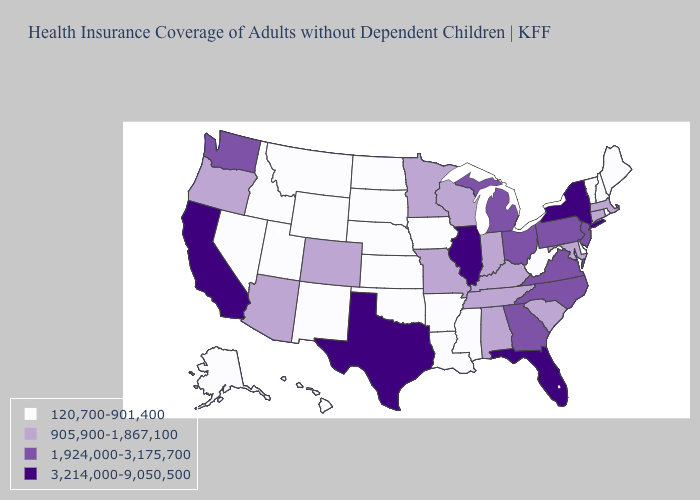What is the value of Florida?
Give a very brief answer. 3,214,000-9,050,500. What is the highest value in the USA?
Concise answer only. 3,214,000-9,050,500. Is the legend a continuous bar?
Keep it brief. No. Name the states that have a value in the range 120,700-901,400?
Give a very brief answer. Alaska, Arkansas, Delaware, Hawaii, Idaho, Iowa, Kansas, Louisiana, Maine, Mississippi, Montana, Nebraska, Nevada, New Hampshire, New Mexico, North Dakota, Oklahoma, Rhode Island, South Dakota, Utah, Vermont, West Virginia, Wyoming. Name the states that have a value in the range 3,214,000-9,050,500?
Answer briefly. California, Florida, Illinois, New York, Texas. Which states have the lowest value in the Northeast?
Answer briefly. Maine, New Hampshire, Rhode Island, Vermont. What is the value of Indiana?
Give a very brief answer. 905,900-1,867,100. What is the value of Georgia?
Keep it brief. 1,924,000-3,175,700. How many symbols are there in the legend?
Be succinct. 4. What is the value of Oklahoma?
Be succinct. 120,700-901,400. Does Nebraska have the highest value in the USA?
Be succinct. No. How many symbols are there in the legend?
Keep it brief. 4. Does South Dakota have the same value as Delaware?
Quick response, please. Yes. Does Louisiana have the same value as Wisconsin?
Quick response, please. No. Among the states that border Georgia , which have the highest value?
Be succinct. Florida. 